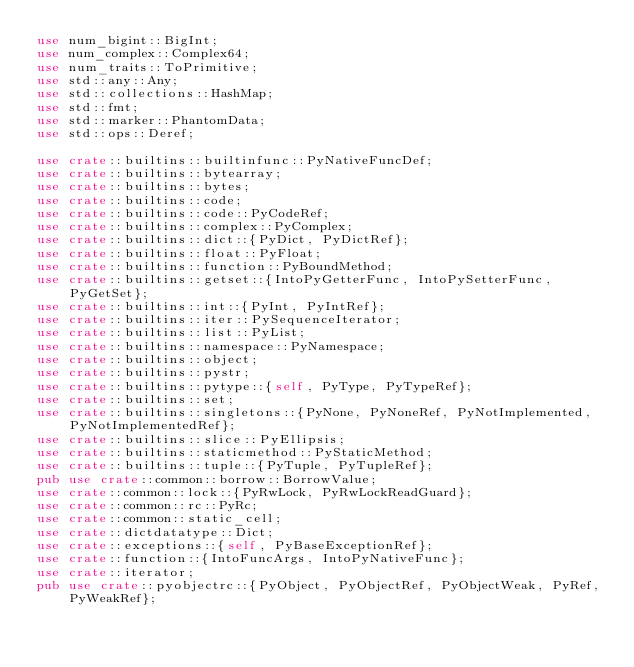<code> <loc_0><loc_0><loc_500><loc_500><_Rust_>use num_bigint::BigInt;
use num_complex::Complex64;
use num_traits::ToPrimitive;
use std::any::Any;
use std::collections::HashMap;
use std::fmt;
use std::marker::PhantomData;
use std::ops::Deref;

use crate::builtins::builtinfunc::PyNativeFuncDef;
use crate::builtins::bytearray;
use crate::builtins::bytes;
use crate::builtins::code;
use crate::builtins::code::PyCodeRef;
use crate::builtins::complex::PyComplex;
use crate::builtins::dict::{PyDict, PyDictRef};
use crate::builtins::float::PyFloat;
use crate::builtins::function::PyBoundMethod;
use crate::builtins::getset::{IntoPyGetterFunc, IntoPySetterFunc, PyGetSet};
use crate::builtins::int::{PyInt, PyIntRef};
use crate::builtins::iter::PySequenceIterator;
use crate::builtins::list::PyList;
use crate::builtins::namespace::PyNamespace;
use crate::builtins::object;
use crate::builtins::pystr;
use crate::builtins::pytype::{self, PyType, PyTypeRef};
use crate::builtins::set;
use crate::builtins::singletons::{PyNone, PyNoneRef, PyNotImplemented, PyNotImplementedRef};
use crate::builtins::slice::PyEllipsis;
use crate::builtins::staticmethod::PyStaticMethod;
use crate::builtins::tuple::{PyTuple, PyTupleRef};
pub use crate::common::borrow::BorrowValue;
use crate::common::lock::{PyRwLock, PyRwLockReadGuard};
use crate::common::rc::PyRc;
use crate::common::static_cell;
use crate::dictdatatype::Dict;
use crate::exceptions::{self, PyBaseExceptionRef};
use crate::function::{IntoFuncArgs, IntoPyNativeFunc};
use crate::iterator;
pub use crate::pyobjectrc::{PyObject, PyObjectRef, PyObjectWeak, PyRef, PyWeakRef};</code> 